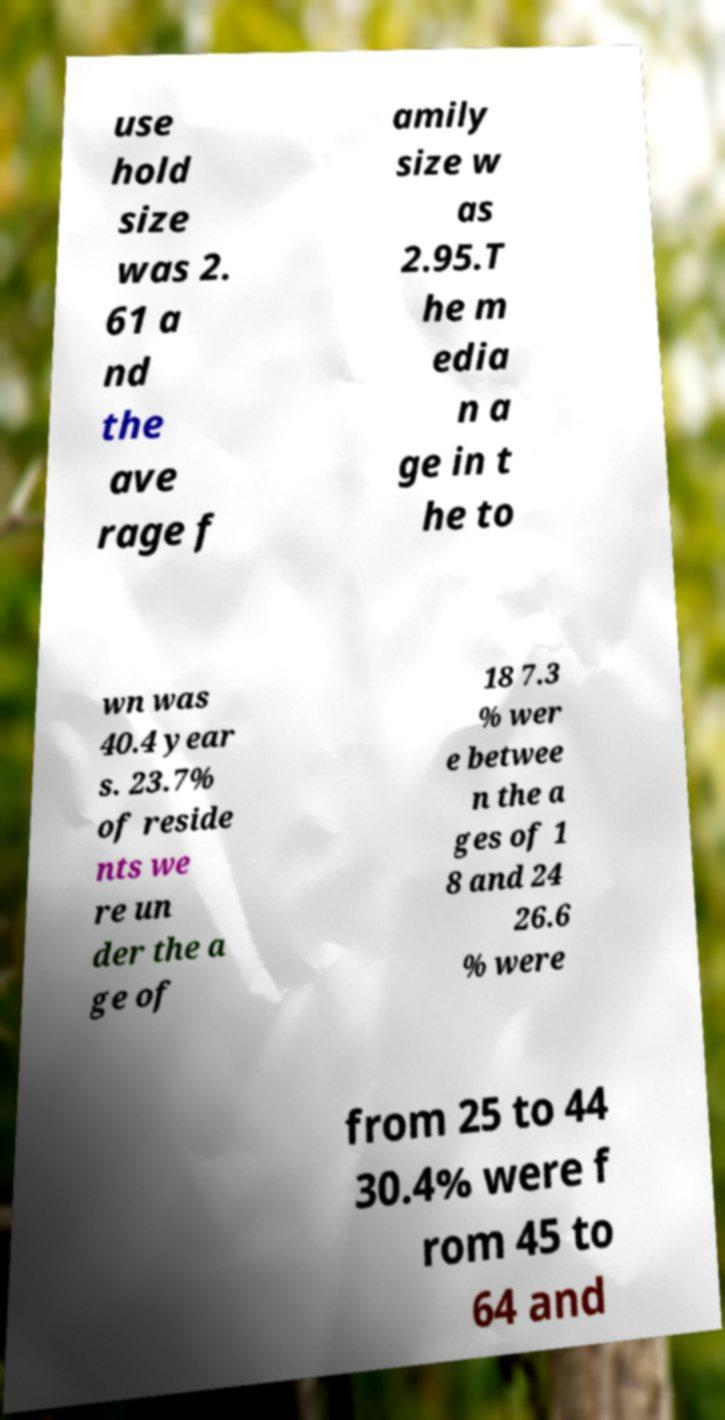Can you read and provide the text displayed in the image?This photo seems to have some interesting text. Can you extract and type it out for me? use hold size was 2. 61 a nd the ave rage f amily size w as 2.95.T he m edia n a ge in t he to wn was 40.4 year s. 23.7% of reside nts we re un der the a ge of 18 7.3 % wer e betwee n the a ges of 1 8 and 24 26.6 % were from 25 to 44 30.4% were f rom 45 to 64 and 